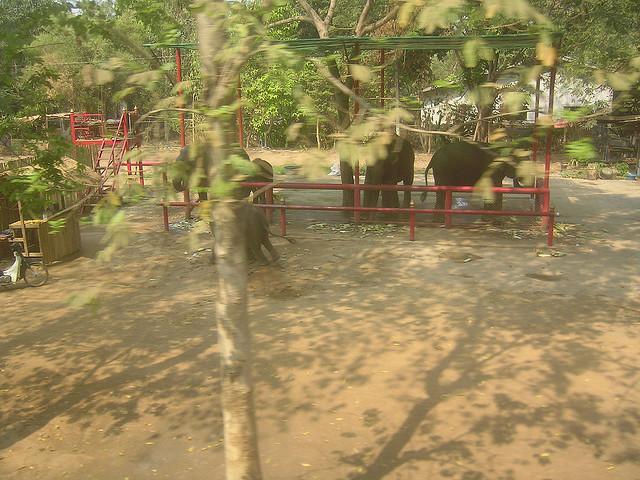Is that bamboo on the top of the shelter?
Concise answer only. Yes. Are the animals in the background or in the foreground?
Answer briefly. Background. How many leaves are on the tree?
Short answer required. 50. What kind of animal is this?
Answer briefly. Elephant. 